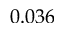Convert formula to latex. <formula><loc_0><loc_0><loc_500><loc_500>0 . 0 3 6</formula> 